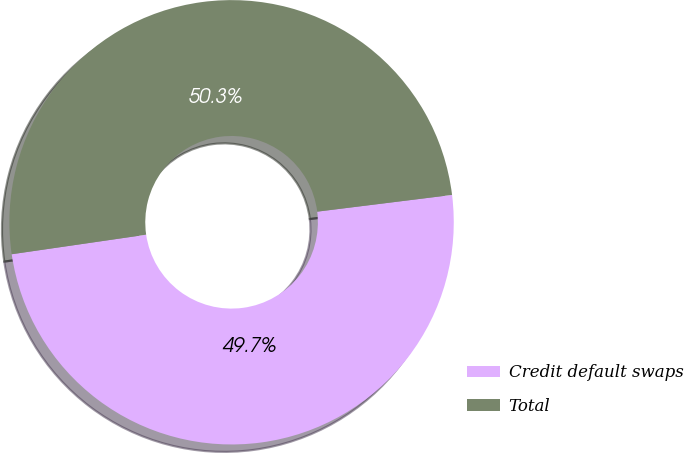Convert chart. <chart><loc_0><loc_0><loc_500><loc_500><pie_chart><fcel>Credit default swaps<fcel>Total<nl><fcel>49.67%<fcel>50.33%<nl></chart> 